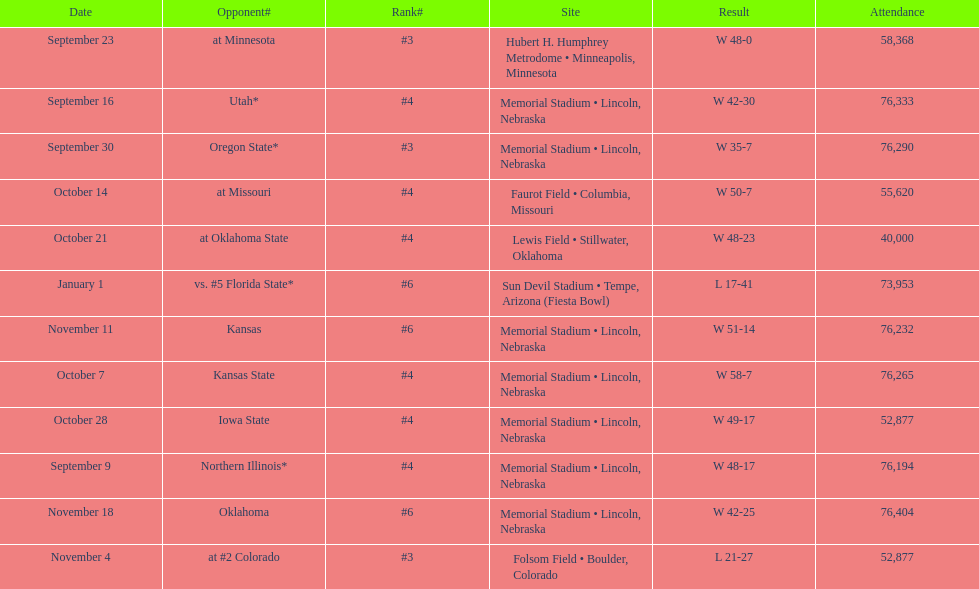In this chart, which month appears the least number of times? January. 